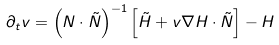Convert formula to latex. <formula><loc_0><loc_0><loc_500><loc_500>\partial _ { t } v = \left ( N \cdot \tilde { N } \right ) ^ { - 1 } \left [ \tilde { H } + v \nabla H \cdot \tilde { N } \right ] - H</formula> 